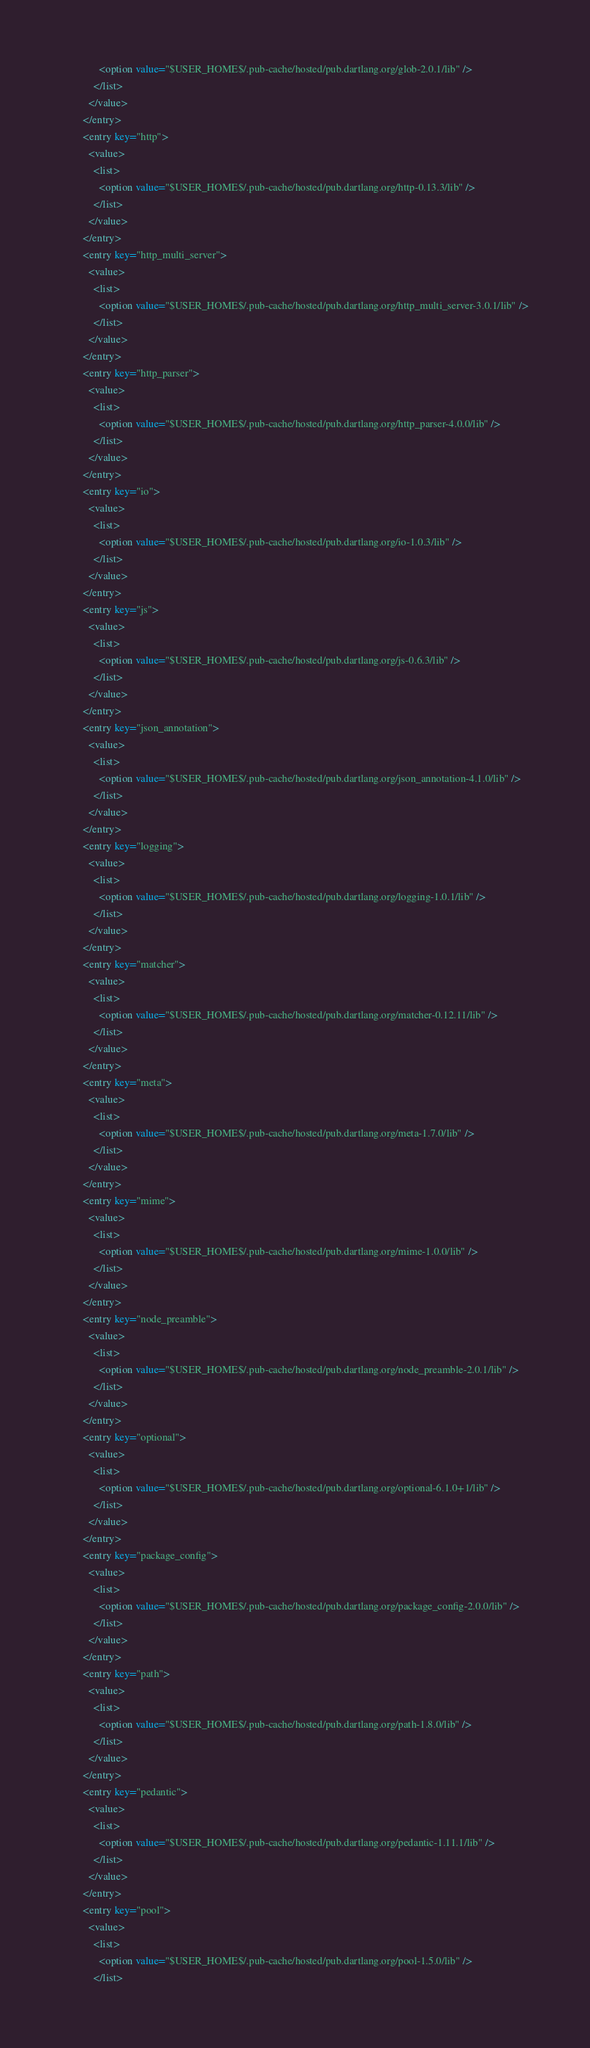<code> <loc_0><loc_0><loc_500><loc_500><_XML_>              <option value="$USER_HOME$/.pub-cache/hosted/pub.dartlang.org/glob-2.0.1/lib" />
            </list>
          </value>
        </entry>
        <entry key="http">
          <value>
            <list>
              <option value="$USER_HOME$/.pub-cache/hosted/pub.dartlang.org/http-0.13.3/lib" />
            </list>
          </value>
        </entry>
        <entry key="http_multi_server">
          <value>
            <list>
              <option value="$USER_HOME$/.pub-cache/hosted/pub.dartlang.org/http_multi_server-3.0.1/lib" />
            </list>
          </value>
        </entry>
        <entry key="http_parser">
          <value>
            <list>
              <option value="$USER_HOME$/.pub-cache/hosted/pub.dartlang.org/http_parser-4.0.0/lib" />
            </list>
          </value>
        </entry>
        <entry key="io">
          <value>
            <list>
              <option value="$USER_HOME$/.pub-cache/hosted/pub.dartlang.org/io-1.0.3/lib" />
            </list>
          </value>
        </entry>
        <entry key="js">
          <value>
            <list>
              <option value="$USER_HOME$/.pub-cache/hosted/pub.dartlang.org/js-0.6.3/lib" />
            </list>
          </value>
        </entry>
        <entry key="json_annotation">
          <value>
            <list>
              <option value="$USER_HOME$/.pub-cache/hosted/pub.dartlang.org/json_annotation-4.1.0/lib" />
            </list>
          </value>
        </entry>
        <entry key="logging">
          <value>
            <list>
              <option value="$USER_HOME$/.pub-cache/hosted/pub.dartlang.org/logging-1.0.1/lib" />
            </list>
          </value>
        </entry>
        <entry key="matcher">
          <value>
            <list>
              <option value="$USER_HOME$/.pub-cache/hosted/pub.dartlang.org/matcher-0.12.11/lib" />
            </list>
          </value>
        </entry>
        <entry key="meta">
          <value>
            <list>
              <option value="$USER_HOME$/.pub-cache/hosted/pub.dartlang.org/meta-1.7.0/lib" />
            </list>
          </value>
        </entry>
        <entry key="mime">
          <value>
            <list>
              <option value="$USER_HOME$/.pub-cache/hosted/pub.dartlang.org/mime-1.0.0/lib" />
            </list>
          </value>
        </entry>
        <entry key="node_preamble">
          <value>
            <list>
              <option value="$USER_HOME$/.pub-cache/hosted/pub.dartlang.org/node_preamble-2.0.1/lib" />
            </list>
          </value>
        </entry>
        <entry key="optional">
          <value>
            <list>
              <option value="$USER_HOME$/.pub-cache/hosted/pub.dartlang.org/optional-6.1.0+1/lib" />
            </list>
          </value>
        </entry>
        <entry key="package_config">
          <value>
            <list>
              <option value="$USER_HOME$/.pub-cache/hosted/pub.dartlang.org/package_config-2.0.0/lib" />
            </list>
          </value>
        </entry>
        <entry key="path">
          <value>
            <list>
              <option value="$USER_HOME$/.pub-cache/hosted/pub.dartlang.org/path-1.8.0/lib" />
            </list>
          </value>
        </entry>
        <entry key="pedantic">
          <value>
            <list>
              <option value="$USER_HOME$/.pub-cache/hosted/pub.dartlang.org/pedantic-1.11.1/lib" />
            </list>
          </value>
        </entry>
        <entry key="pool">
          <value>
            <list>
              <option value="$USER_HOME$/.pub-cache/hosted/pub.dartlang.org/pool-1.5.0/lib" />
            </list></code> 